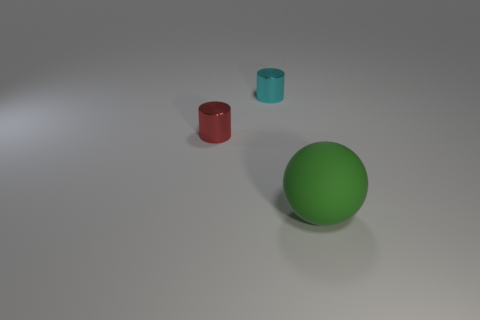Add 1 big green matte objects. How many objects exist? 4 Subtract all cylinders. How many objects are left? 1 Add 3 tiny cyan metal objects. How many tiny cyan metal objects are left? 4 Add 3 large green balls. How many large green balls exist? 4 Subtract 0 yellow cylinders. How many objects are left? 3 Subtract all brown cubes. Subtract all green balls. How many objects are left? 2 